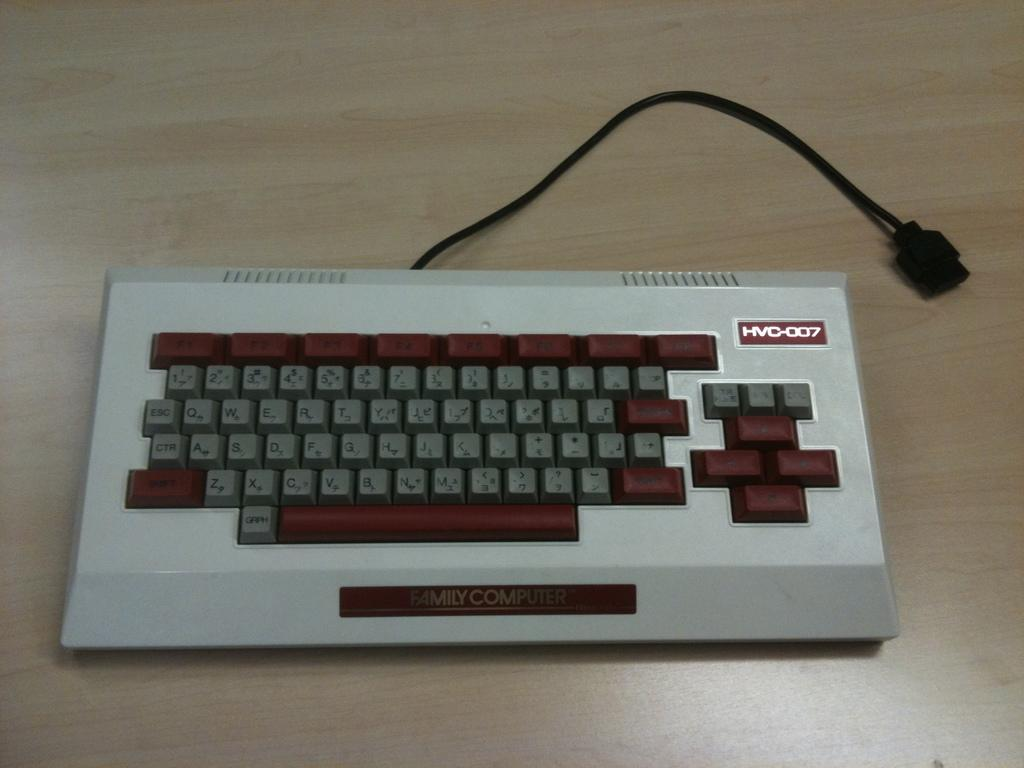<image>
Write a terse but informative summary of the picture. An HVC-007 model keyboard is on a table. 